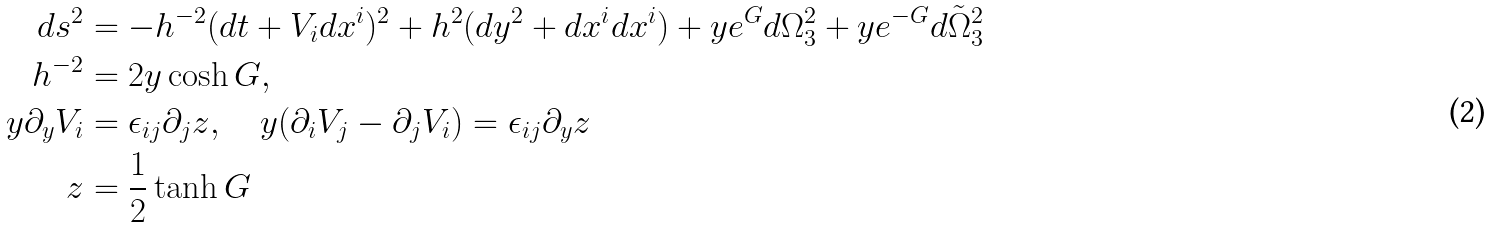Convert formula to latex. <formula><loc_0><loc_0><loc_500><loc_500>d s ^ { 2 } & = - h ^ { - 2 } ( d t + V _ { i } d x ^ { i } ) ^ { 2 } + h ^ { 2 } ( d y ^ { 2 } + d x ^ { i } d x ^ { i } ) + y e ^ { G } d \Omega _ { 3 } ^ { 2 } + y e ^ { - G } d \tilde { \Omega } _ { 3 } ^ { 2 } \\ h ^ { - 2 } & = 2 y \cosh G , \\ y \partial _ { y } V _ { i } & = \epsilon _ { i j } \partial _ { j } z , \quad y ( \partial _ { i } V _ { j } - \partial _ { j } V _ { i } ) = \epsilon _ { i j } \partial _ { y } z \\ z & = \frac { 1 } { 2 } \tanh G \\</formula> 